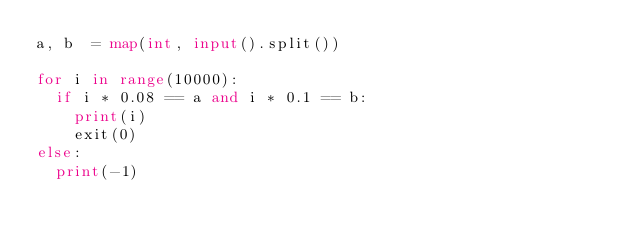<code> <loc_0><loc_0><loc_500><loc_500><_Python_>a, b  = map(int, input().split())

for i in range(10000):
  if i * 0.08 == a and i * 0.1 == b:
    print(i)
    exit(0)
else:
  print(-1)
    
    
</code> 